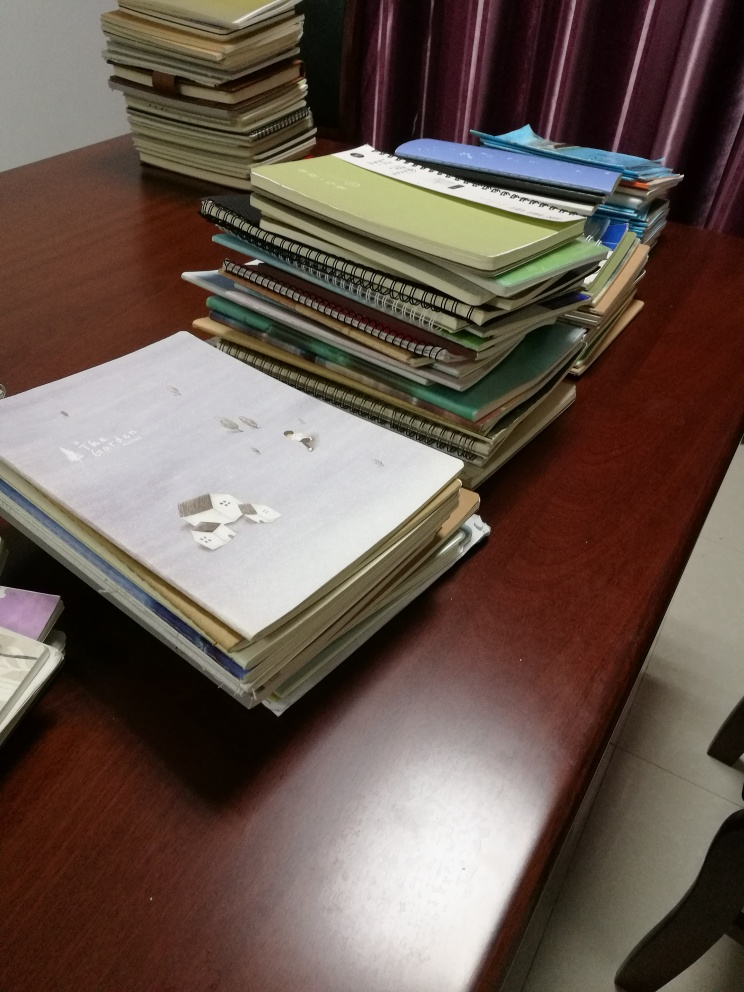Can you tell me more about the items on the desk? Certainly! The desk is cluttered with an assortment of notebooks, ring binders, and stacks of papers, suggesting an environment that is scholarly or related to someone engaged in study or research. There's a notable variety of colors and sizes among the items, and the organized chaos could imply a person who is busy but methodical in their work. 